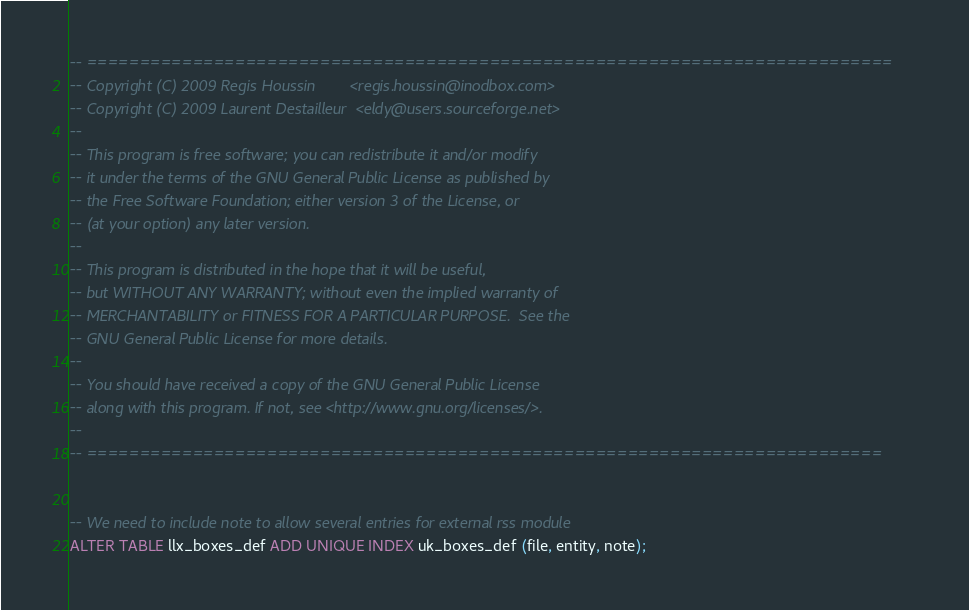<code> <loc_0><loc_0><loc_500><loc_500><_SQL_>-- ============================================================================
-- Copyright (C) 2009 Regis Houssin        <regis.houssin@inodbox.com>
-- Copyright (C) 2009 Laurent Destailleur  <eldy@users.sourceforge.net>
--
-- This program is free software; you can redistribute it and/or modify
-- it under the terms of the GNU General Public License as published by
-- the Free Software Foundation; either version 3 of the License, or
-- (at your option) any later version.
--
-- This program is distributed in the hope that it will be useful,
-- but WITHOUT ANY WARRANTY; without even the implied warranty of
-- MERCHANTABILITY or FITNESS FOR A PARTICULAR PURPOSE.  See the
-- GNU General Public License for more details.
--
-- You should have received a copy of the GNU General Public License
-- along with this program. If not, see <http://www.gnu.org/licenses/>.
--
-- ===========================================================================


-- We need to include note to allow several entries for external rss module
ALTER TABLE llx_boxes_def ADD UNIQUE INDEX uk_boxes_def (file, entity, note);
</code> 